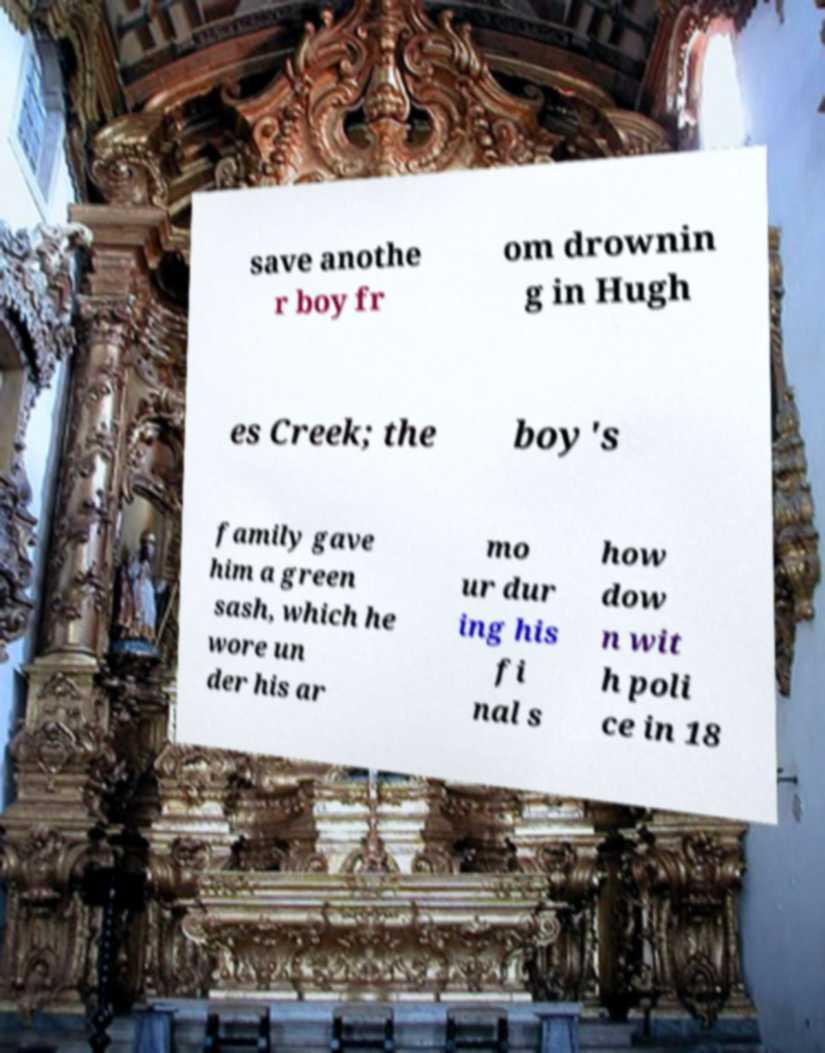Could you assist in decoding the text presented in this image and type it out clearly? save anothe r boy fr om drownin g in Hugh es Creek; the boy's family gave him a green sash, which he wore un der his ar mo ur dur ing his fi nal s how dow n wit h poli ce in 18 